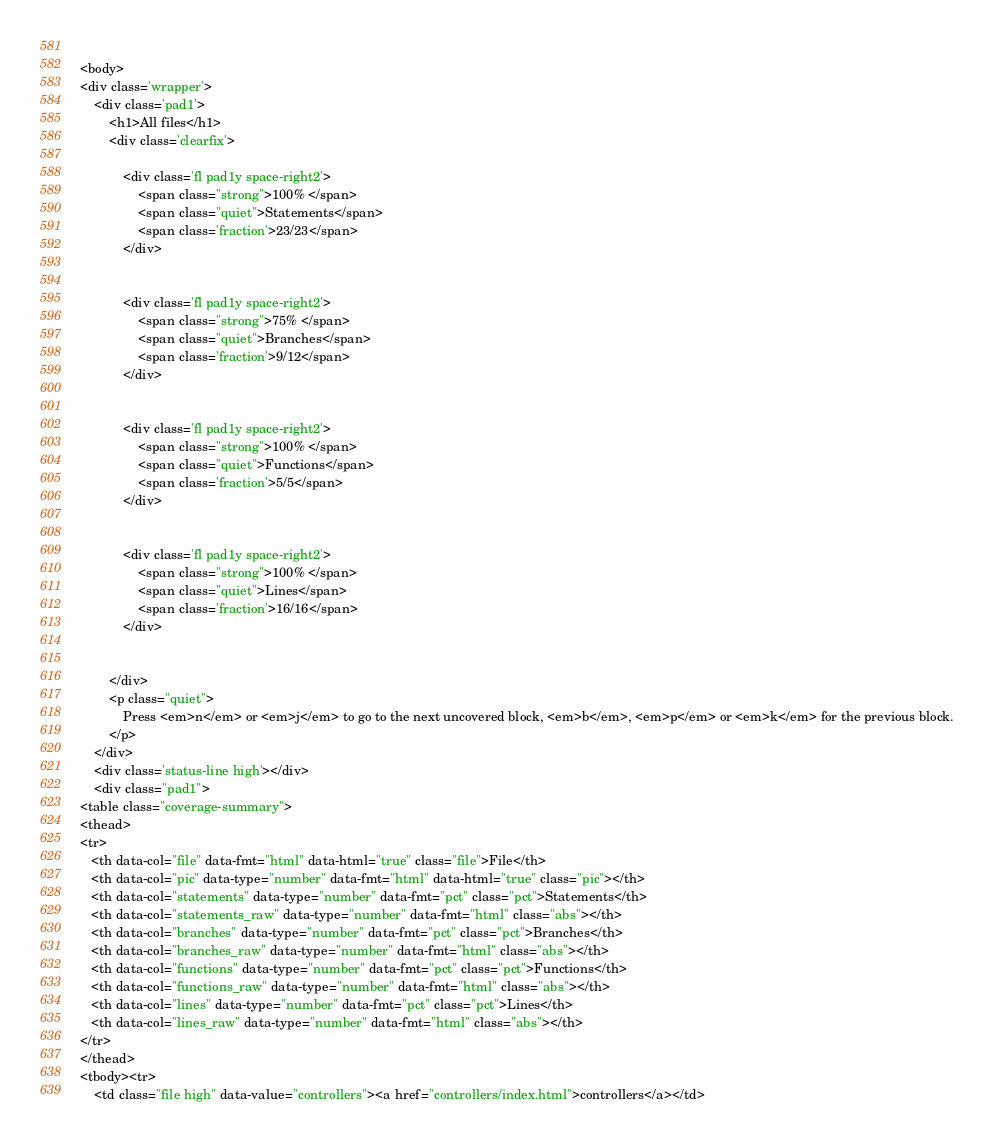<code> <loc_0><loc_0><loc_500><loc_500><_HTML_>    
<body>
<div class='wrapper'>
    <div class='pad1'>
        <h1>All files</h1>
        <div class='clearfix'>
            
            <div class='fl pad1y space-right2'>
                <span class="strong">100% </span>
                <span class="quiet">Statements</span>
                <span class='fraction'>23/23</span>
            </div>
        
            
            <div class='fl pad1y space-right2'>
                <span class="strong">75% </span>
                <span class="quiet">Branches</span>
                <span class='fraction'>9/12</span>
            </div>
        
            
            <div class='fl pad1y space-right2'>
                <span class="strong">100% </span>
                <span class="quiet">Functions</span>
                <span class='fraction'>5/5</span>
            </div>
        
            
            <div class='fl pad1y space-right2'>
                <span class="strong">100% </span>
                <span class="quiet">Lines</span>
                <span class='fraction'>16/16</span>
            </div>
        
            
        </div>
        <p class="quiet">
            Press <em>n</em> or <em>j</em> to go to the next uncovered block, <em>b</em>, <em>p</em> or <em>k</em> for the previous block.
        </p>
    </div>
    <div class='status-line high'></div>
    <div class="pad1">
<table class="coverage-summary">
<thead>
<tr>
   <th data-col="file" data-fmt="html" data-html="true" class="file">File</th>
   <th data-col="pic" data-type="number" data-fmt="html" data-html="true" class="pic"></th>
   <th data-col="statements" data-type="number" data-fmt="pct" class="pct">Statements</th>
   <th data-col="statements_raw" data-type="number" data-fmt="html" class="abs"></th>
   <th data-col="branches" data-type="number" data-fmt="pct" class="pct">Branches</th>
   <th data-col="branches_raw" data-type="number" data-fmt="html" class="abs"></th>
   <th data-col="functions" data-type="number" data-fmt="pct" class="pct">Functions</th>
   <th data-col="functions_raw" data-type="number" data-fmt="html" class="abs"></th>
   <th data-col="lines" data-type="number" data-fmt="pct" class="pct">Lines</th>
   <th data-col="lines_raw" data-type="number" data-fmt="html" class="abs"></th>
</tr>
</thead>
<tbody><tr>
	<td class="file high" data-value="controllers"><a href="controllers/index.html">controllers</a></td></code> 